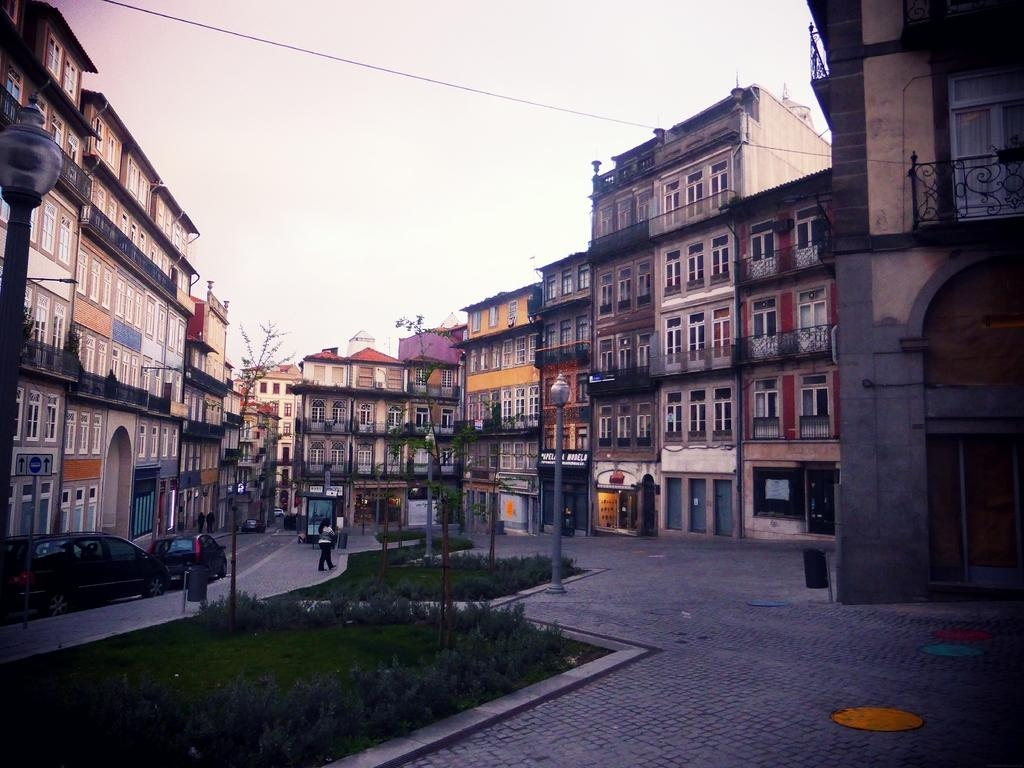What type of surface is visible in the image? There is a grass surface in the image. What structures are present on the grass surface? There are poles with lamps in the image. What else can be seen in the image besides the grass surface and poles with lamps? There is a road, people standing on the road, and buildings visible in the image. What is visible in the background of the image? The sky is visible in the background of the image. How many geese are flying over the buildings in the image? There are no geese visible in the image; it only features a grass surface, poles with lamps, a road, people standing on the road, buildings, and the sky in the background. What type of stamp is being used by the people standing on the road in the image? There is no mention of a stamp in the image; it only features a grass surface, poles with lamps, a road, people standing on the road, buildings, and the sky in the background. 